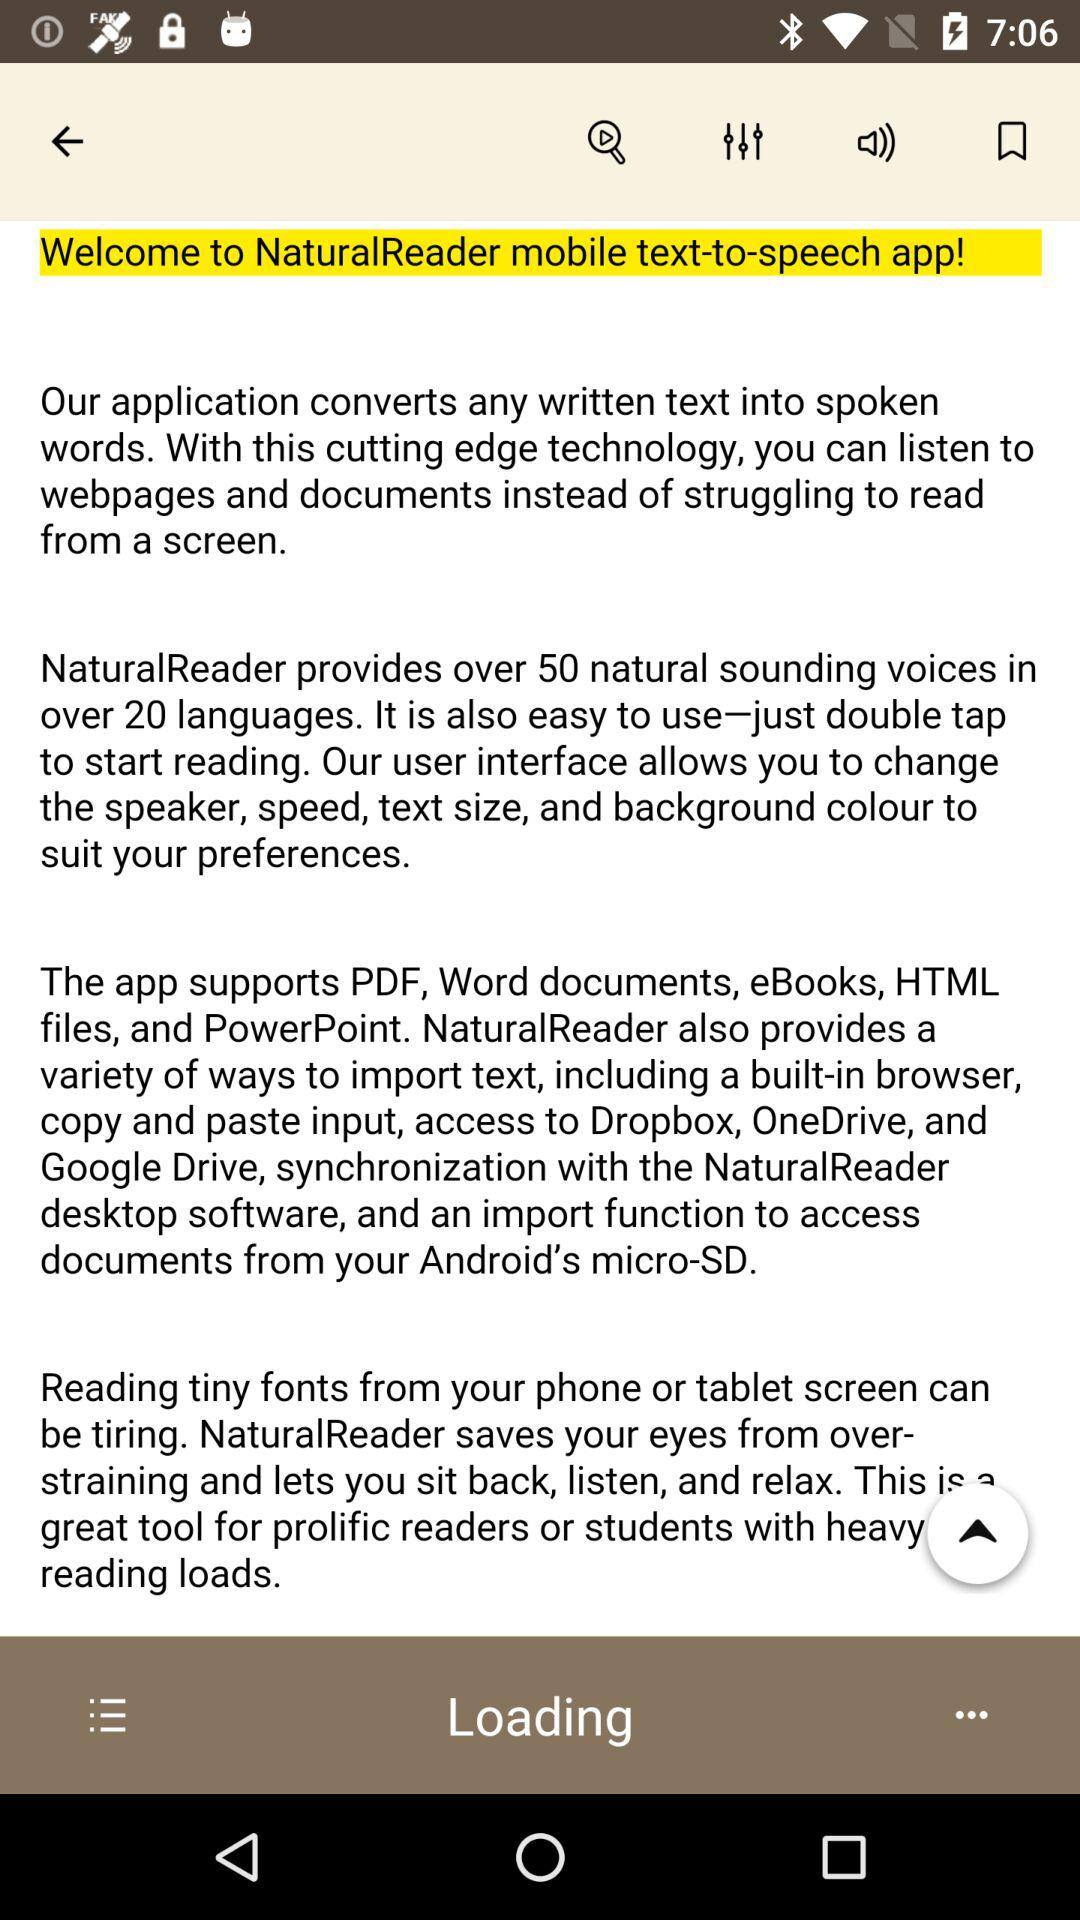What file types does the "NaturalReader" app support? The app supports PDF, Word documents, eBooks, HTML files, and PowerPoint. 